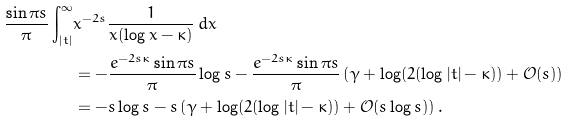Convert formula to latex. <formula><loc_0><loc_0><loc_500><loc_500>\frac { \sin \pi s } { \pi } \int _ { | t | } ^ { \infty } & x ^ { - 2 s } \frac { 1 } { x ( \log x - \kappa ) } \, d x \\ & = - \frac { e ^ { - 2 s \kappa } \sin \pi s } { \pi } \log s - \frac { e ^ { - 2 s \kappa } \sin \pi s } { \pi } \left ( \gamma + \log ( 2 ( \log | t | - \kappa ) ) + \mathcal { O } ( s ) \right ) \\ & = - s \log s - s \left ( \gamma + \log ( 2 ( \log | t | - \kappa ) ) + \mathcal { O } ( s \log s ) \right ) .</formula> 